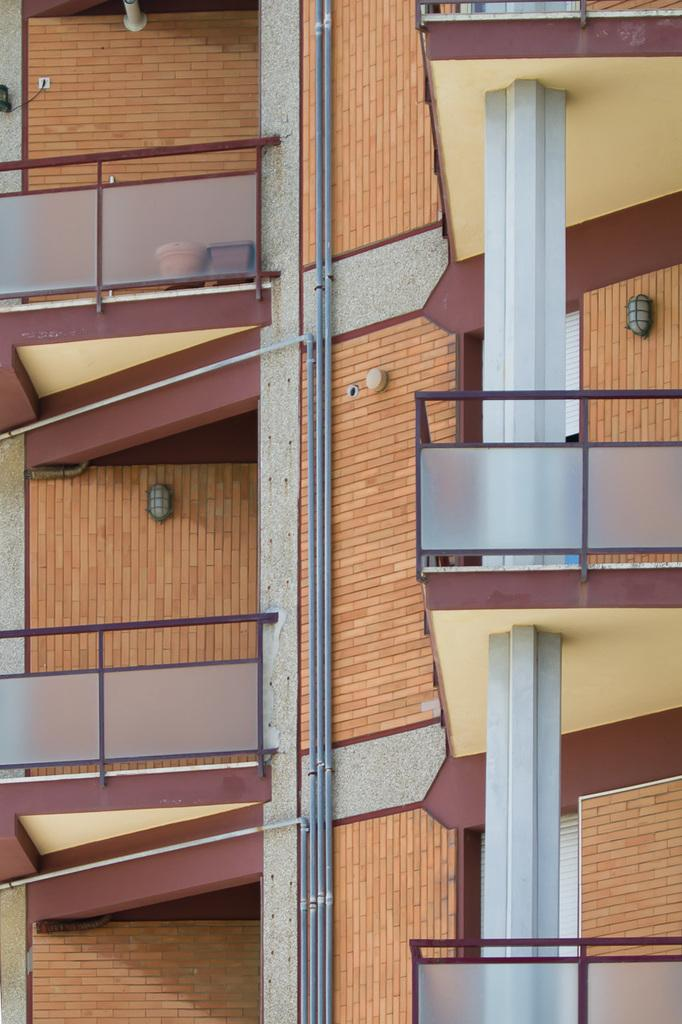What type of structure is depicted in the image? The image is of a building. What materials can be seen within the building? There are pipes, iron rods, pots, and lights visible in the building. Are there any pets visible in the image? There are no pets present in the image; it features a building with various materials and objects. What type of fan can be seen in the image? There is no fan present in the image. 